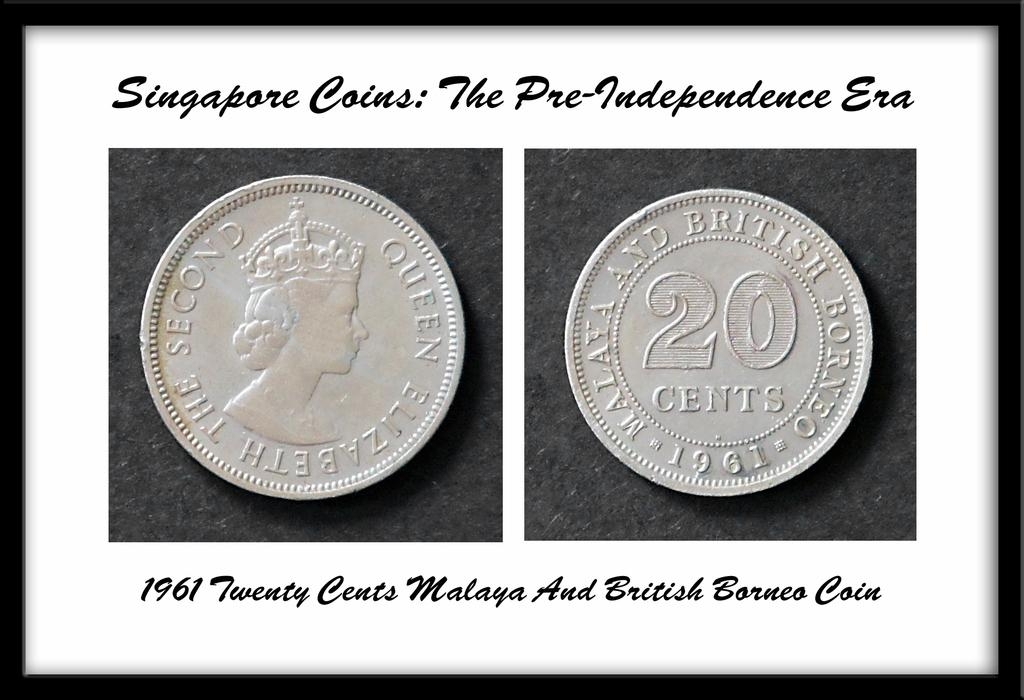<image>
Present a compact description of the photo's key features. The front and back view of a Singapore coin from 1961. 